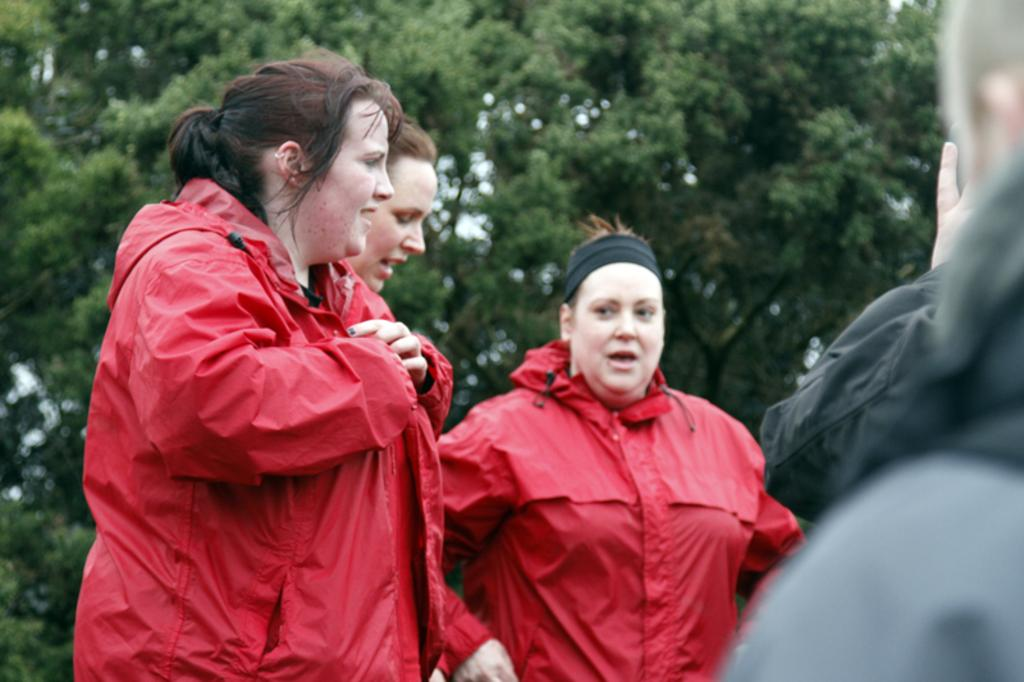What can be seen in the image? There are people standing in the image. What is visible in the background of the image? There are trees in the background of the image. How many sisters are teaching in the image? There is no mention of sisters or teaching in the image; it only shows people standing in front of trees. 